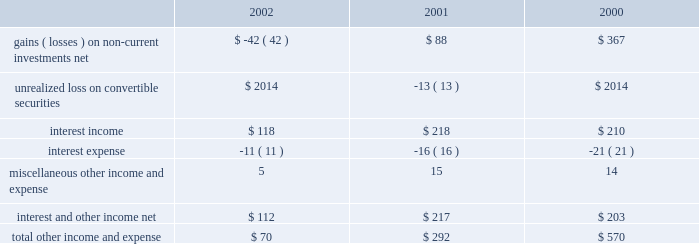Other income and expense for the three fiscal years ended september 28 , 2002 are as follows ( in millions ) : gains and losses on non-current investments investments categorized as non-current debt and equity investments on the consolidated balance sheet are in equity and debt instruments of public companies .
The company's non-current debt and equity investments , and certain investments in private companies carried in other assets , have been categorized as available-for-sale requiring that they be carried at fair value with unrealized gains and losses , net of taxes , reported in equity as a component of accumulated other comprehensive income .
However , the company recognizes an impairment charge to earnings in the event a decline in fair value below the cost basis of one of these investments is determined to be other-than-temporary .
The company includes recognized gains and losses resulting from the sale or from other-than-temporary declines in fair value associated with these investments in other income and expense .
Further information related to the company's non-current debt and equity investments may be found in part ii , item 8 of this form 10-k at note 2 of notes to consolidated financial statements .
During 2002 , the company determined that declines in the fair value of certain of these investments were other-than-temporary .
As a result , the company recognized a $ 44 million charge to earnings to write-down the basis of its investment in earthlink , inc .
( earthlink ) , a $ 6 million charge to earnings to write-down the basis of its investment in akamai technologies , inc .
( akamai ) , and a $ 15 million charge to earnings to write-down the basis of its investment in a private company investment .
These losses in 2002 were partially offset by the sale of 117000 shares of earthlink stock for net proceeds of $ 2 million and a gain before taxes of $ 223000 , the sale of 250000 shares of akamai stock for net proceeds of $ 2 million and a gain before taxes of $ 710000 , and the sale of approximately 4.7 million shares of arm holdings plc ( arm ) stock for both net proceeds and a gain before taxes of $ 21 million .
During 2001 , the company sold a total of approximately 1 million shares of akamai stock for net proceeds of $ 39 million and recorded a gain before taxes of $ 36 million , and sold a total of approximately 29.8 million shares of arm stock for net proceeds of $ 176 million and recorded a gain before taxes of $ 174 million .
These gains during 2001 were partially offset by a $ 114 million charge to earnings that reflected an other- than-temporary decline in the fair value of the company's investment in earthlink and an $ 8 million charge that reflected an other-than- temporary decline in the fair value of certain private company investments .
During 2000 , the company sold a total of approximately 45.2 million shares of arm stock for net proceeds of $ 372 million and a gain before taxes of $ 367 million .
The combined carrying value of the company's investments in earthlink , akamai , and arm as of september 28 , 2002 , was $ 39 million .
The company believes it is likely there will continue to be significant fluctuations in the fair value of these investments in the future .
Accounting for derivatives and cumulative effect of accounting change on october 1 , 2000 , the company adopted statement of financial accounting standard ( sfas ) no .
133 , accounting for derivative instruments and hedging activities .
Sfas no .
133 established accounting and reporting standards for derivative instruments , hedging activities , and exposure definition .
Net of the related income tax effect of approximately $ 5 million , adoption of sfas no .
133 resulted in a favorable cumulative-effect-type adjustment to net income of approximately $ 12 million for the first quarter of 2001 .
The $ 17 million gross transition adjustment was comprised of a $ 23 million favorable adjustment for the restatement to fair value of the derivative component of the company's investment in samsung electronics co. , ltd .
( samsung ) , partially offset by the unfavorable adjustments to certain foreign currency and interest rate derivatives .
Sfas no .
133 also required the company to adjust the carrying value of the derivative component of its investment in samsung to earnings during the first quarter of 2001 , the before tax effect of which was an unrealized loss of approximately $ 13 million .
Interest and other income , net net interest and other income was $ 112 million in fiscal 2002 , compared to $ 217 million in fiscal 2001 .
This $ 105 million or 48% ( 48 % ) decrease is .
Total other income and expense .
What was the greatest amount of total other income and expense , in millions? 
Computations: table_max(total other income and expense, none)
Answer: 570.0. Other income and expense for the three fiscal years ended september 28 , 2002 are as follows ( in millions ) : gains and losses on non-current investments investments categorized as non-current debt and equity investments on the consolidated balance sheet are in equity and debt instruments of public companies .
The company's non-current debt and equity investments , and certain investments in private companies carried in other assets , have been categorized as available-for-sale requiring that they be carried at fair value with unrealized gains and losses , net of taxes , reported in equity as a component of accumulated other comprehensive income .
However , the company recognizes an impairment charge to earnings in the event a decline in fair value below the cost basis of one of these investments is determined to be other-than-temporary .
The company includes recognized gains and losses resulting from the sale or from other-than-temporary declines in fair value associated with these investments in other income and expense .
Further information related to the company's non-current debt and equity investments may be found in part ii , item 8 of this form 10-k at note 2 of notes to consolidated financial statements .
During 2002 , the company determined that declines in the fair value of certain of these investments were other-than-temporary .
As a result , the company recognized a $ 44 million charge to earnings to write-down the basis of its investment in earthlink , inc .
( earthlink ) , a $ 6 million charge to earnings to write-down the basis of its investment in akamai technologies , inc .
( akamai ) , and a $ 15 million charge to earnings to write-down the basis of its investment in a private company investment .
These losses in 2002 were partially offset by the sale of 117000 shares of earthlink stock for net proceeds of $ 2 million and a gain before taxes of $ 223000 , the sale of 250000 shares of akamai stock for net proceeds of $ 2 million and a gain before taxes of $ 710000 , and the sale of approximately 4.7 million shares of arm holdings plc ( arm ) stock for both net proceeds and a gain before taxes of $ 21 million .
During 2001 , the company sold a total of approximately 1 million shares of akamai stock for net proceeds of $ 39 million and recorded a gain before taxes of $ 36 million , and sold a total of approximately 29.8 million shares of arm stock for net proceeds of $ 176 million and recorded a gain before taxes of $ 174 million .
These gains during 2001 were partially offset by a $ 114 million charge to earnings that reflected an other- than-temporary decline in the fair value of the company's investment in earthlink and an $ 8 million charge that reflected an other-than- temporary decline in the fair value of certain private company investments .
During 2000 , the company sold a total of approximately 45.2 million shares of arm stock for net proceeds of $ 372 million and a gain before taxes of $ 367 million .
The combined carrying value of the company's investments in earthlink , akamai , and arm as of september 28 , 2002 , was $ 39 million .
The company believes it is likely there will continue to be significant fluctuations in the fair value of these investments in the future .
Accounting for derivatives and cumulative effect of accounting change on october 1 , 2000 , the company adopted statement of financial accounting standard ( sfas ) no .
133 , accounting for derivative instruments and hedging activities .
Sfas no .
133 established accounting and reporting standards for derivative instruments , hedging activities , and exposure definition .
Net of the related income tax effect of approximately $ 5 million , adoption of sfas no .
133 resulted in a favorable cumulative-effect-type adjustment to net income of approximately $ 12 million for the first quarter of 2001 .
The $ 17 million gross transition adjustment was comprised of a $ 23 million favorable adjustment for the restatement to fair value of the derivative component of the company's investment in samsung electronics co. , ltd .
( samsung ) , partially offset by the unfavorable adjustments to certain foreign currency and interest rate derivatives .
Sfas no .
133 also required the company to adjust the carrying value of the derivative component of its investment in samsung to earnings during the first quarter of 2001 , the before tax effect of which was an unrealized loss of approximately $ 13 million .
Interest and other income , net net interest and other income was $ 112 million in fiscal 2002 , compared to $ 217 million in fiscal 2001 .
This $ 105 million or 48% ( 48 % ) decrease is .
Total other income and expense .
What was the change in millions of total other income and expense from 2001 to 2002? 
Computations: (70 - 292)
Answer: -222.0. 